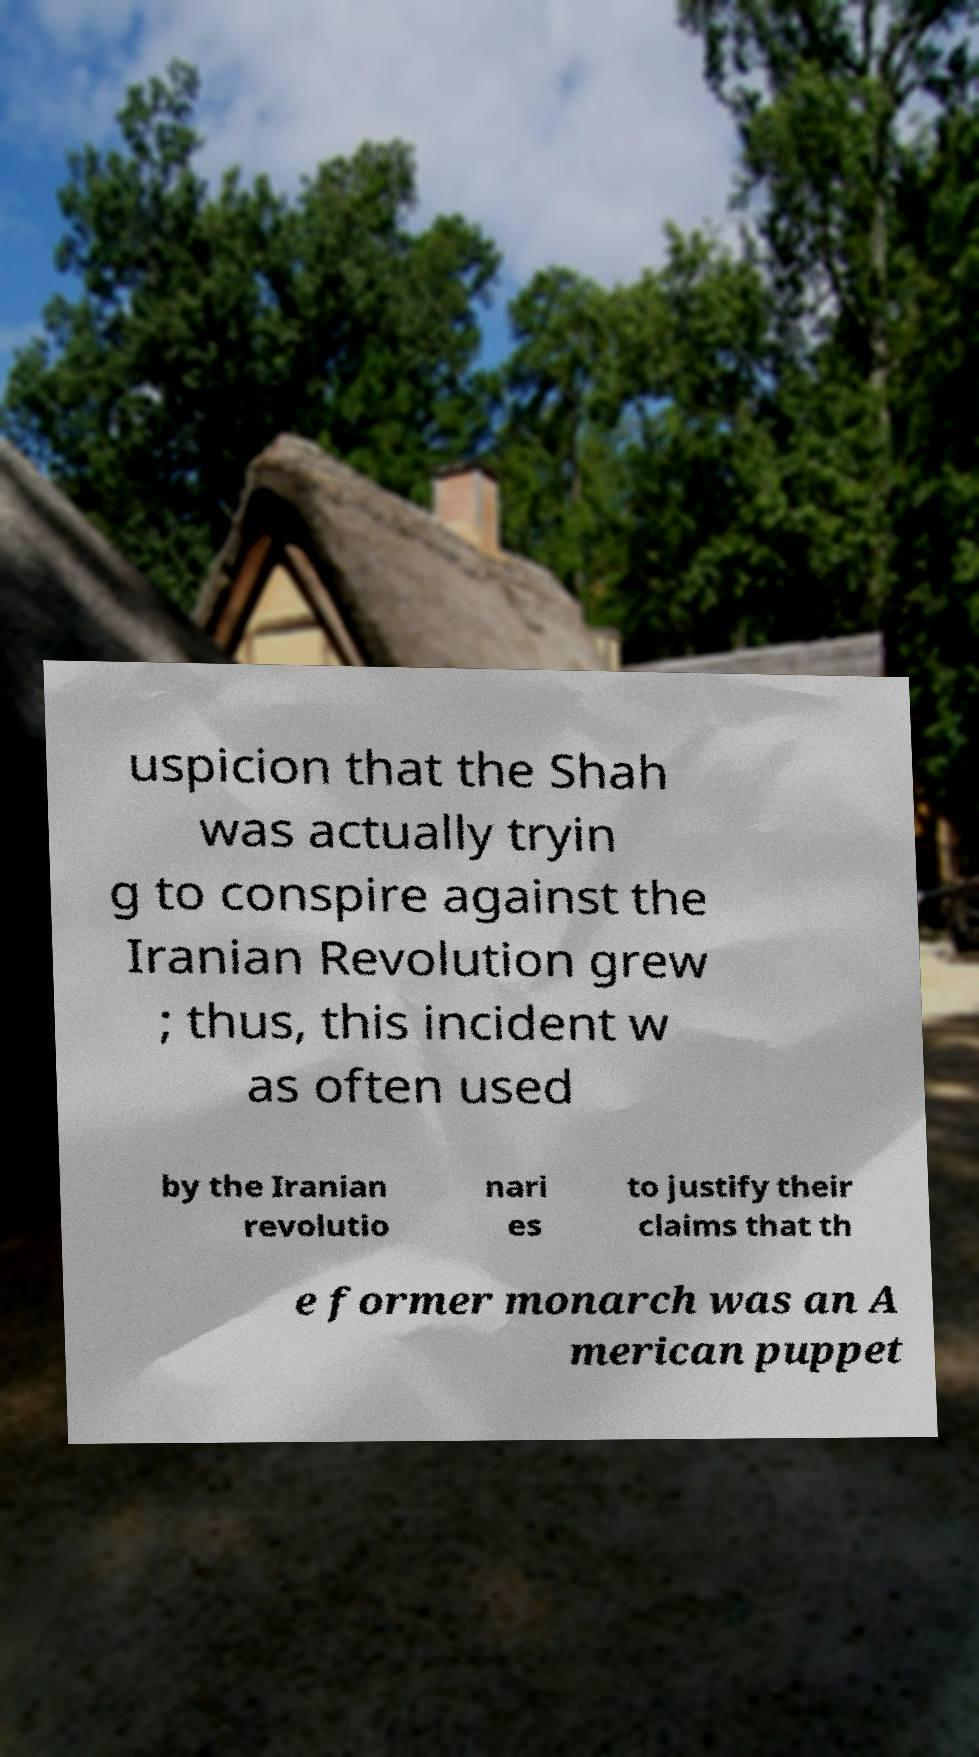What messages or text are displayed in this image? I need them in a readable, typed format. uspicion that the Shah was actually tryin g to conspire against the Iranian Revolution grew ; thus, this incident w as often used by the Iranian revolutio nari es to justify their claims that th e former monarch was an A merican puppet 